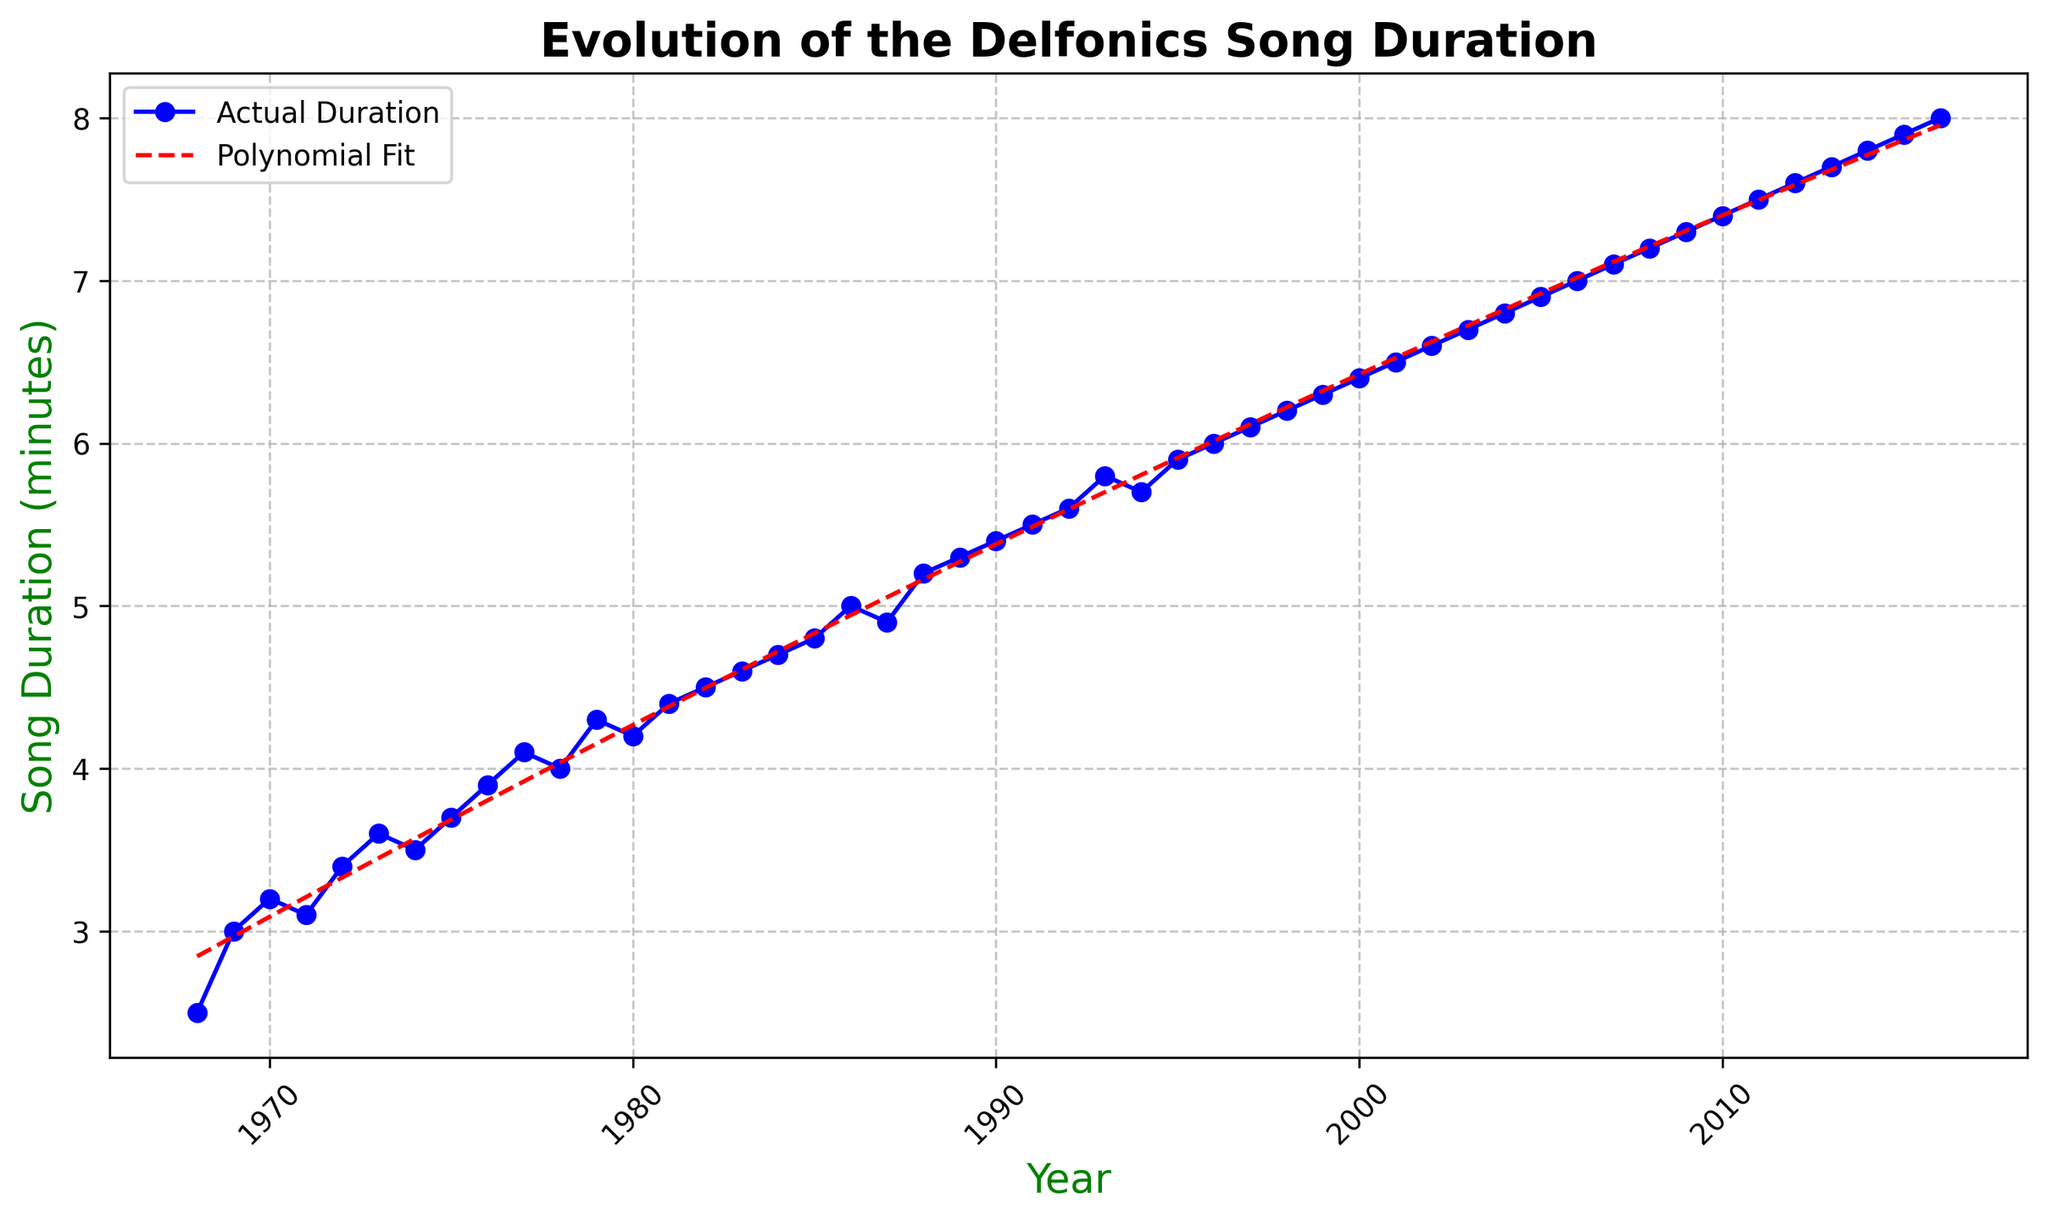What is the trend of song durations from 1968 to 2016? The plot shows the song durations increasing over time. From 1968 to 2016, the Delfonics' song durations appear to have a generally upward trend, indicating that their songs have become longer over the years.
Answer: Increasing What was the song duration of the Delfonics in 1980, and how does it compare to 2016? According to the plot, the song duration in 1980 was about 4.2 minutes. In 2016, the duration was about 8.0 minutes. Comparing these two points, the song duration in 2016 is almost twice that of 1980.
Answer: 4.2 minutes in 1980, 8.0 minutes in 2016 During which decade did the song durations of the Delfonics show the most significant increase? By examining the plot, the most significant increase in song durations seems to occur between the 1980s and the 1990s. The slope of the polynomial fit line appears steepest during this period.
Answer: 1980s-1990s Is there any period where the song duration slightly decreases or remains stable? The polynomial fit line and actual data points show that around 1974 and 1978, the song durations either slightly decreased or remained relatively stable compared to nearby years.
Answer: Around 1974 to 1978 Compare the actual duration and the polynomial fit in the year 1979. What do you observe? By referring to the plot, in 1979, the actual song duration is approximately 4.3 minutes, while the polynomial fit shows a slight deviation around that value. This indicates that while the polynomial fit line is generally accurate, there are some variations in specific years.
Answer: Actual: 4.3 minutes, Polynomial Fit: Slight deviation By how many minutes did the song duration change from 1990 to 2000? In the plot, the song duration in 1990 is approximately 5.4 minutes, and in 2000, it’s around 6.4 minutes. The change in song duration over this period is 6.4 - 5.4 = 1.0 minutes.
Answer: 1.0 minutes How can you describe the relationship between the actual duration trends and the polynomial fit during the 1970s and early 1980s? The plot shows that during the 1970s and early 1980s, the polynomial fit closely follows the actual song duration data points, indicating a good model fit. There are minor deviations, but overall, this period's trends align well with the polynomial regression line.
Answer: Polynomial fit closely follows actual trend Does the polynomial regression fit suggest a continuous increase in song duration beyond the data range? The polynomial fit line suggests a continuous increase in song duration, as the line continues to slope upwards even beyond the last data point in 2016. This implies a prediction of further increase if the trend continues.
Answer: Yes, continuous increase What is the significance of the dotted red line in the plot? The dotted red line represents the polynomial regression fit, which approximates the evolving trend of song durations over the years. It provides a smoothed curve that fits the actual song duration data points, highlighting the overall trend.
Answer: Polynomial regression fit 